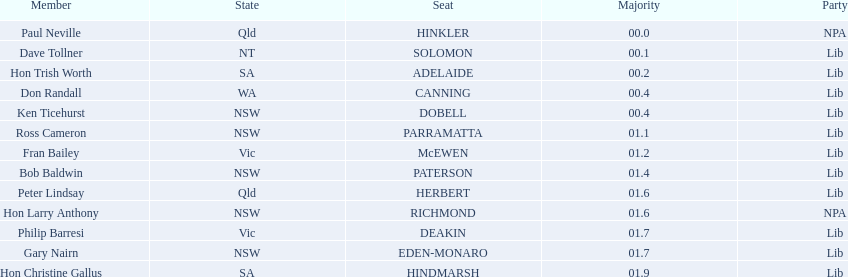What state does hinkler belong too? Qld. What is the majority of difference between sa and qld? 01.9. 